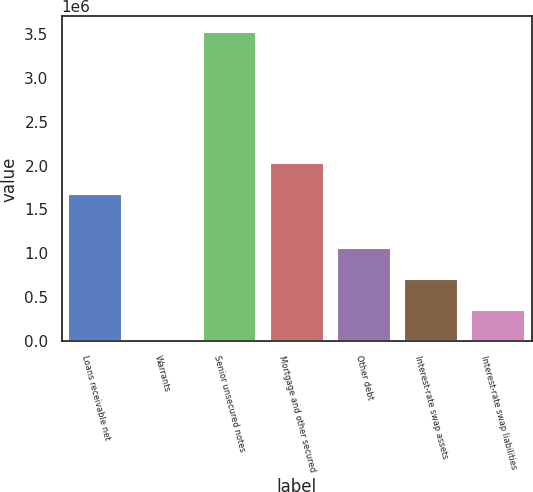Convert chart to OTSL. <chart><loc_0><loc_0><loc_500><loc_500><bar_chart><fcel>Loans receivable net<fcel>Warrants<fcel>Senior unsecured notes<fcel>Mortgage and other secured<fcel>Other debt<fcel>Interest-rate swap assets<fcel>Interest-rate swap liabilities<nl><fcel>1.67294e+06<fcel>1732<fcel>3.52132e+06<fcel>2.0249e+06<fcel>1.05761e+06<fcel>705651<fcel>353691<nl></chart> 